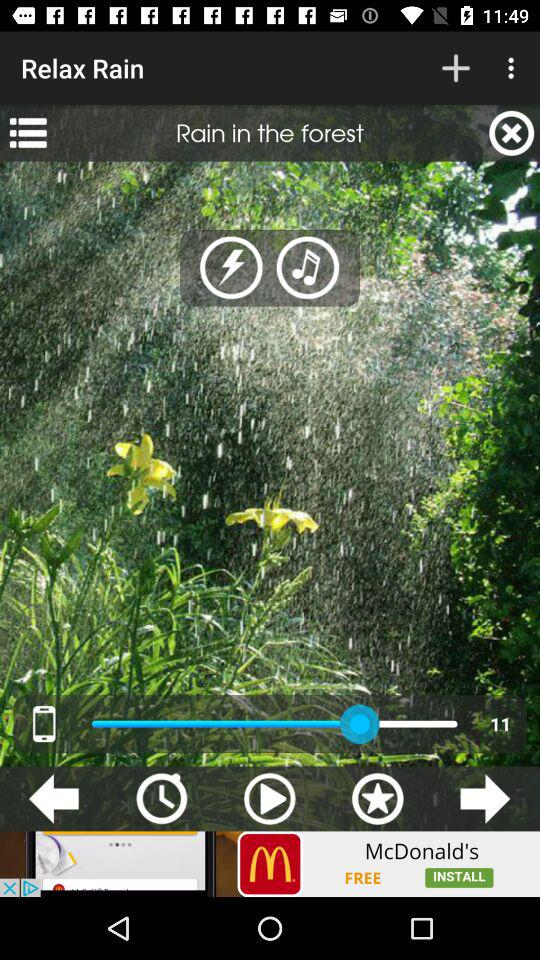What is the name of the sound? The name of the sound is "Rain in the forest". 